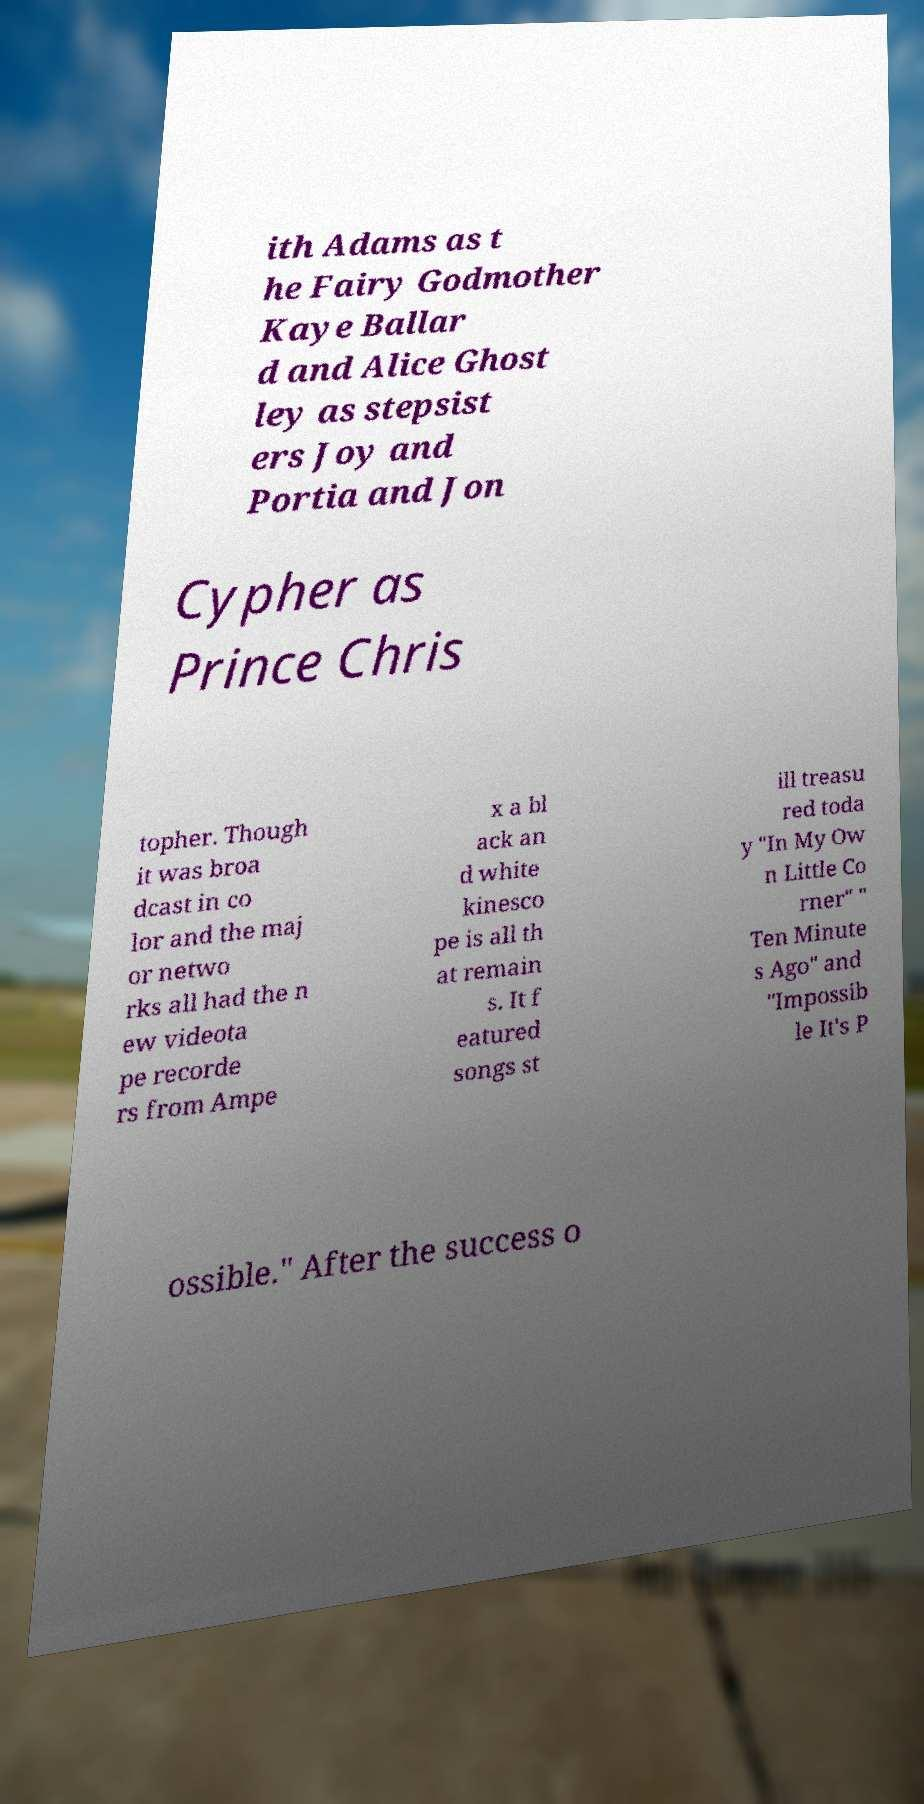Please read and relay the text visible in this image. What does it say? ith Adams as t he Fairy Godmother Kaye Ballar d and Alice Ghost ley as stepsist ers Joy and Portia and Jon Cypher as Prince Chris topher. Though it was broa dcast in co lor and the maj or netwo rks all had the n ew videota pe recorde rs from Ampe x a bl ack an d white kinesco pe is all th at remain s. It f eatured songs st ill treasu red toda y "In My Ow n Little Co rner" " Ten Minute s Ago" and "Impossib le It's P ossible." After the success o 